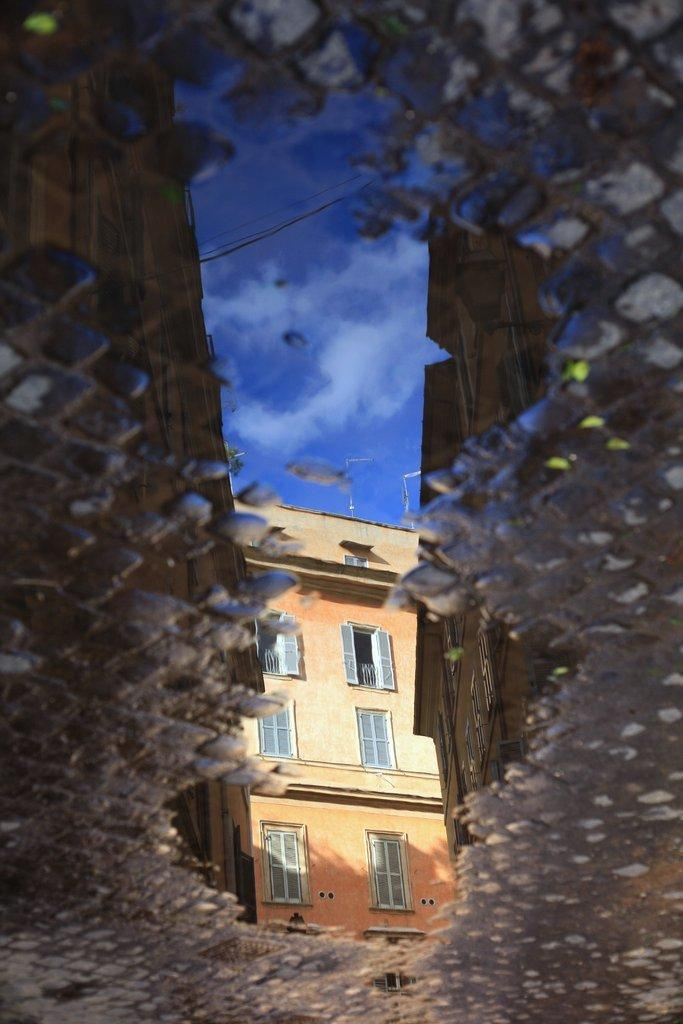What type of structures can be seen in the image? There are buildings in the image. What part of the natural environment is visible in the image? The sky is visible in the image. What can be seen in the sky? Clouds are present in the sky. What else is present in the image besides buildings and clouds? There are wires and it appears that there is water on the ground in the image. How many cakes are being carried by the fowl in the image? There are no fowl or cakes present in the image. What type of ant can be seen climbing the wires in the image? There are no ants visible in the image; only wires are present. 